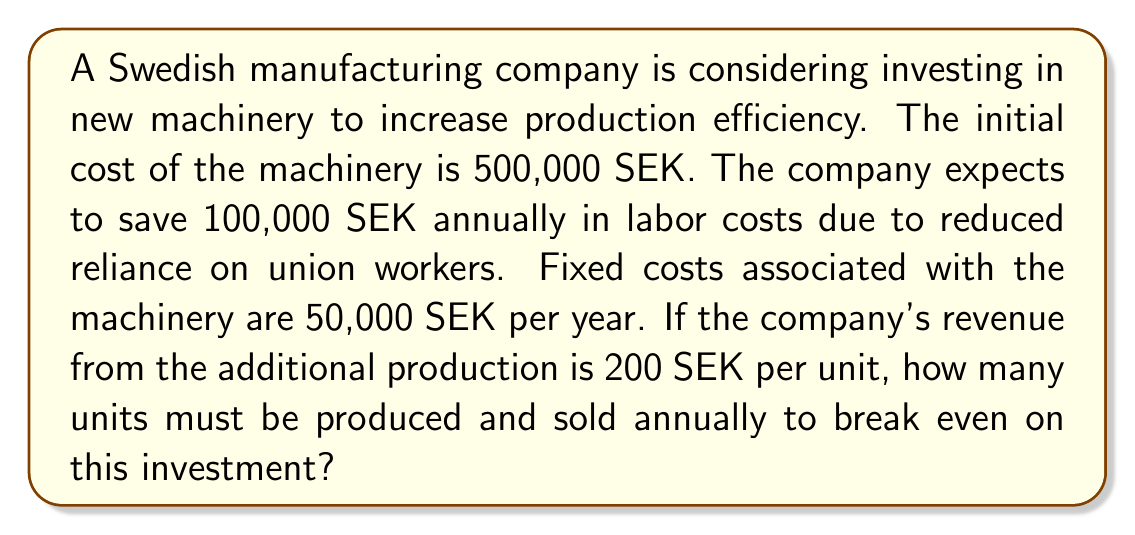Solve this math problem. Let's approach this step-by-step:

1) First, we need to define our variables:
   Let $x$ = number of units produced and sold annually

2) Now, let's set up the break-even equation:
   Revenue = Fixed Costs + Variable Costs

3) In this case:
   - Revenue = 200 SEK per unit * $x$ units = $200x$
   - Fixed Costs = 50,000 SEK (annual) + 500,000 SEK (initial cost) - 100,000 SEK (annual labor savings) = 450,000 SEK
   - Variable Costs = 0 (not given in the problem, assumed to be included in the fixed costs)

4) Our break-even equation becomes:
   $200x = 450,000$

5) Solve for $x$:
   $x = \frac{450,000}{200} = 2,250$

Therefore, the company needs to produce and sell 2,250 units annually to break even on this investment.
Answer: 2,250 units 